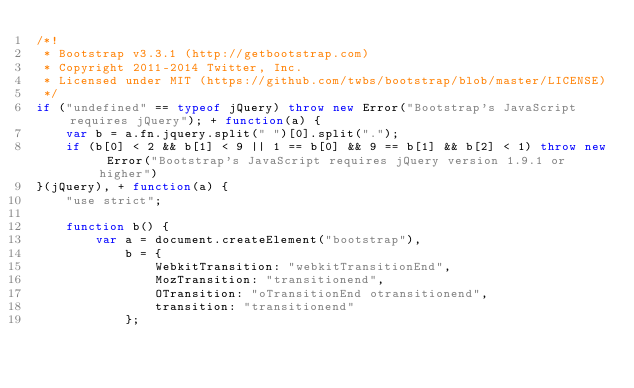Convert code to text. <code><loc_0><loc_0><loc_500><loc_500><_JavaScript_>/*!
 * Bootstrap v3.3.1 (http://getbootstrap.com)
 * Copyright 2011-2014 Twitter, Inc.
 * Licensed under MIT (https://github.com/twbs/bootstrap/blob/master/LICENSE)
 */
if ("undefined" == typeof jQuery) throw new Error("Bootstrap's JavaScript requires jQuery"); + function(a) {
    var b = a.fn.jquery.split(" ")[0].split(".");
    if (b[0] < 2 && b[1] < 9 || 1 == b[0] && 9 == b[1] && b[2] < 1) throw new Error("Bootstrap's JavaScript requires jQuery version 1.9.1 or higher")
}(jQuery), + function(a) {
    "use strict";

    function b() {
        var a = document.createElement("bootstrap"),
            b = {
                WebkitTransition: "webkitTransitionEnd",
                MozTransition: "transitionend",
                OTransition: "oTransitionEnd otransitionend",
                transition: "transitionend"
            };</code> 